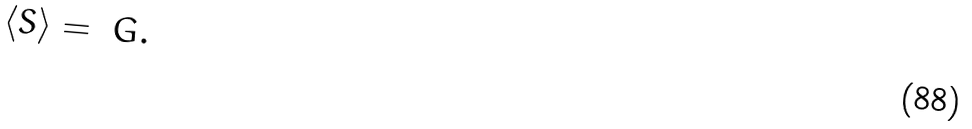<formula> <loc_0><loc_0><loc_500><loc_500>\langle S \rangle = \ G .</formula> 